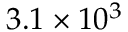Convert formula to latex. <formula><loc_0><loc_0><loc_500><loc_500>3 . 1 \times 1 0 ^ { 3 }</formula> 